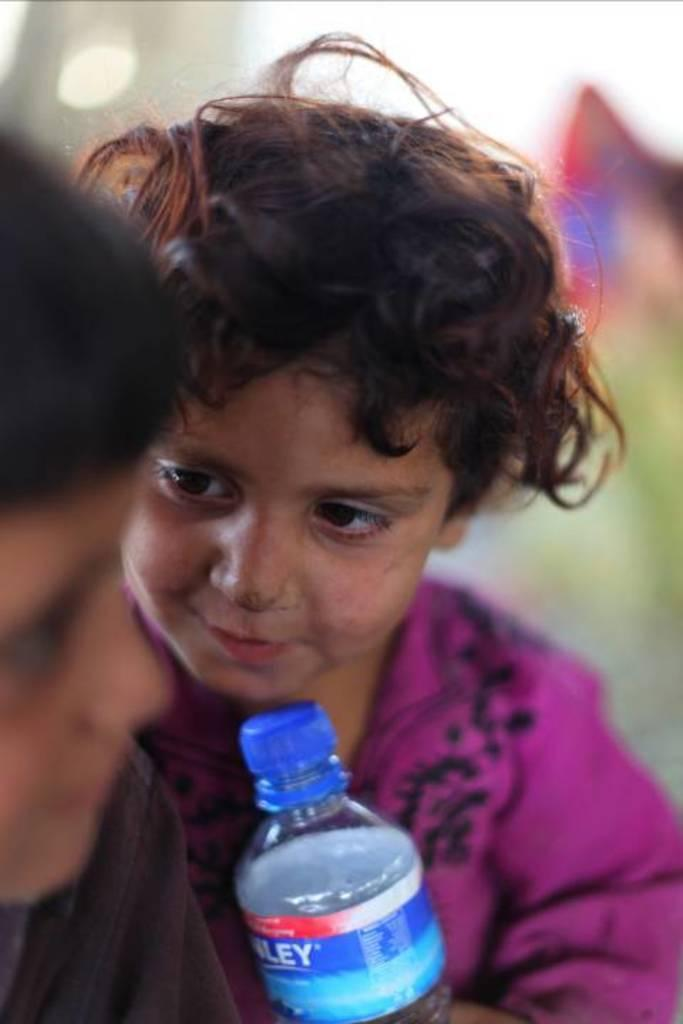What is the child in the image wearing? The child in the image is wearing a pink dress. What object can be seen in the image besides the child? There is a bottle in the image. How many children are present in the image? There are two children in the image. What type of jelly can be seen on the child's face in the image? There is no jelly visible on the child's face in the image. What reason might the children be in the image? The provided facts do not give any information about the reason the children are in the image. 